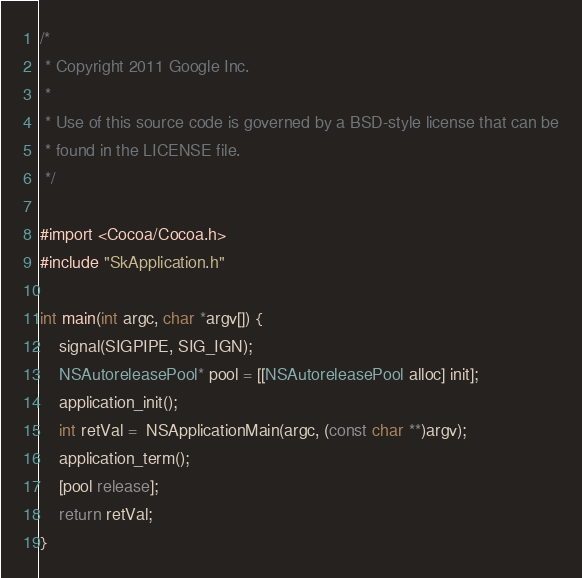<code> <loc_0><loc_0><loc_500><loc_500><_ObjectiveC_>
/*
 * Copyright 2011 Google Inc.
 *
 * Use of this source code is governed by a BSD-style license that can be
 * found in the LICENSE file.
 */

#import <Cocoa/Cocoa.h>
#include "SkApplication.h"

int main(int argc, char *argv[]) {
    signal(SIGPIPE, SIG_IGN);
    NSAutoreleasePool* pool = [[NSAutoreleasePool alloc] init];
    application_init();
    int retVal =  NSApplicationMain(argc, (const char **)argv);
    application_term();
    [pool release];
    return retVal;
}
</code> 